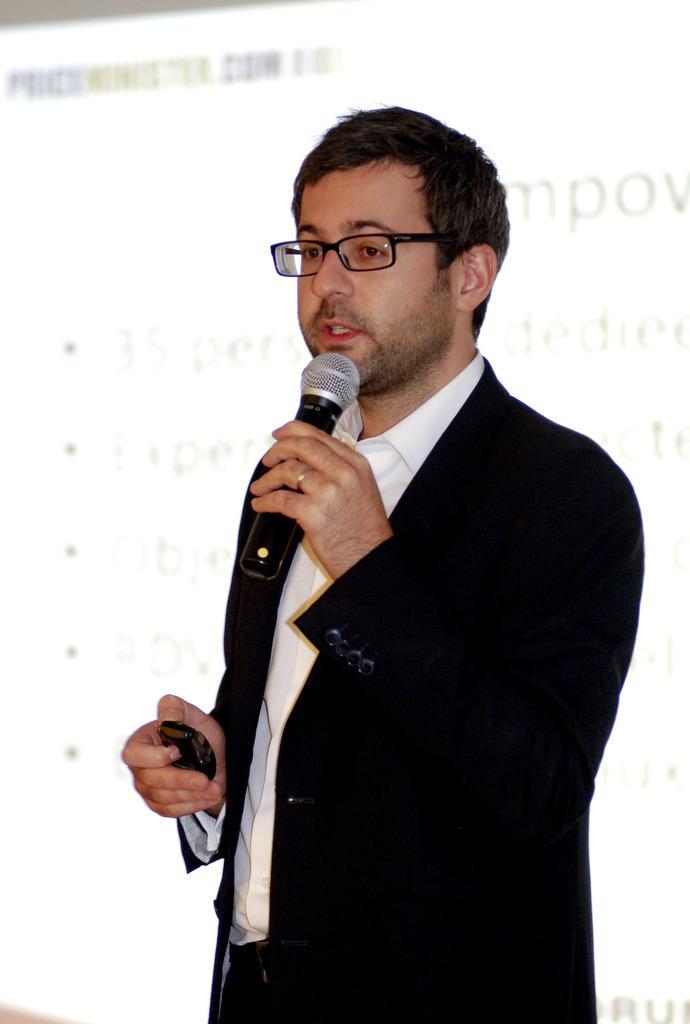How would you summarize this image in a sentence or two? In this image, there is a person wearing clothes and spectacles. This person holding a mic. There is a screen behind this person. 